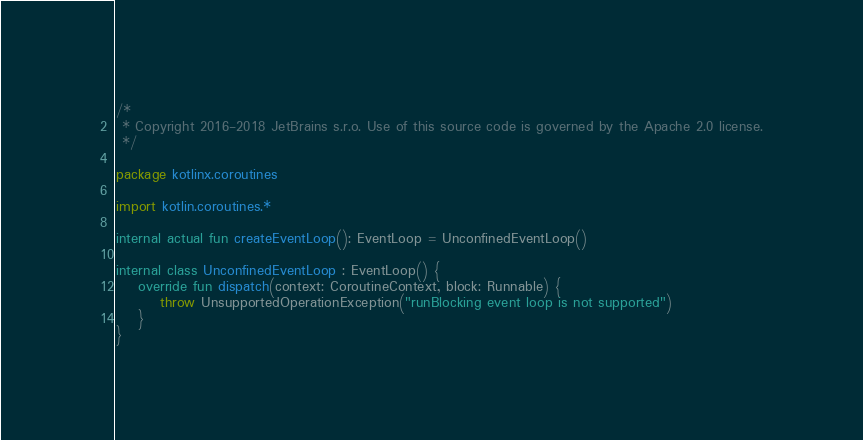Convert code to text. <code><loc_0><loc_0><loc_500><loc_500><_Kotlin_>/*
 * Copyright 2016-2018 JetBrains s.r.o. Use of this source code is governed by the Apache 2.0 license.
 */

package kotlinx.coroutines

import kotlin.coroutines.*

internal actual fun createEventLoop(): EventLoop = UnconfinedEventLoop()

internal class UnconfinedEventLoop : EventLoop() {
    override fun dispatch(context: CoroutineContext, block: Runnable) {
        throw UnsupportedOperationException("runBlocking event loop is not supported")
    }
}
</code> 